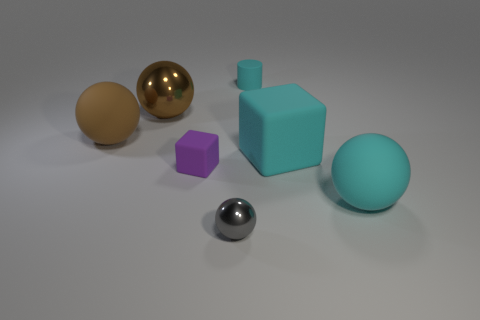Subtract all brown metal spheres. How many spheres are left? 3 Add 1 tiny purple matte blocks. How many objects exist? 8 Subtract all purple blocks. How many blocks are left? 1 Subtract 1 cubes. How many cubes are left? 1 Subtract all yellow cubes. Subtract all green cylinders. How many cubes are left? 2 Subtract all blue cubes. How many red spheres are left? 0 Subtract all gray metal objects. Subtract all large brown rubber things. How many objects are left? 5 Add 7 large brown matte spheres. How many large brown matte spheres are left? 8 Add 1 small blocks. How many small blocks exist? 2 Subtract 0 yellow cylinders. How many objects are left? 7 